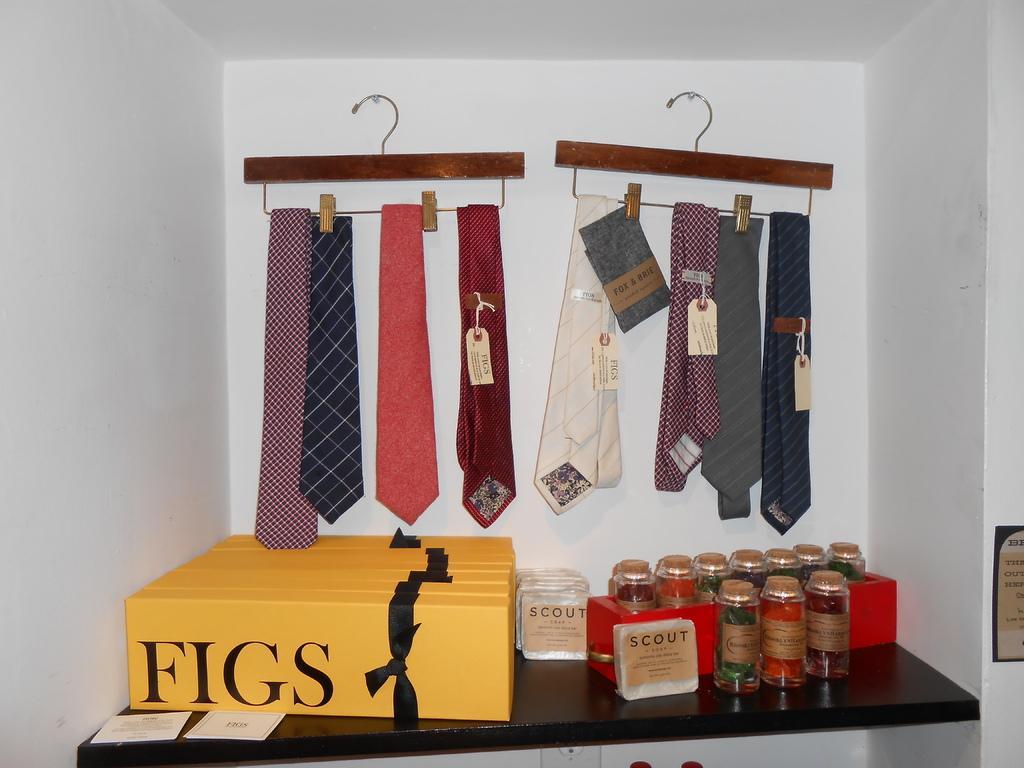Describe this image in one or two sentences. There are boxes, jars in a red color box, jars, packs and cards arranged on the table. Above this table, there are ties hanged on the hangers which are attached to the white wall. 